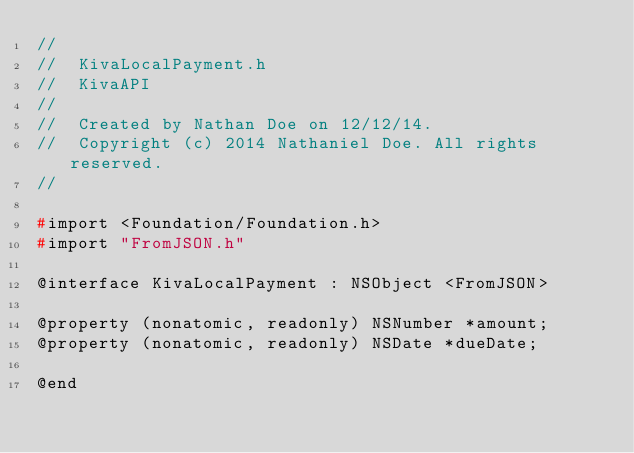<code> <loc_0><loc_0><loc_500><loc_500><_C_>//
//  KivaLocalPayment.h
//  KivaAPI
//
//  Created by Nathan Doe on 12/12/14.
//  Copyright (c) 2014 Nathaniel Doe. All rights reserved.
//

#import <Foundation/Foundation.h>
#import "FromJSON.h"

@interface KivaLocalPayment : NSObject <FromJSON>

@property (nonatomic, readonly) NSNumber *amount;
@property (nonatomic, readonly) NSDate *dueDate;

@end
</code> 